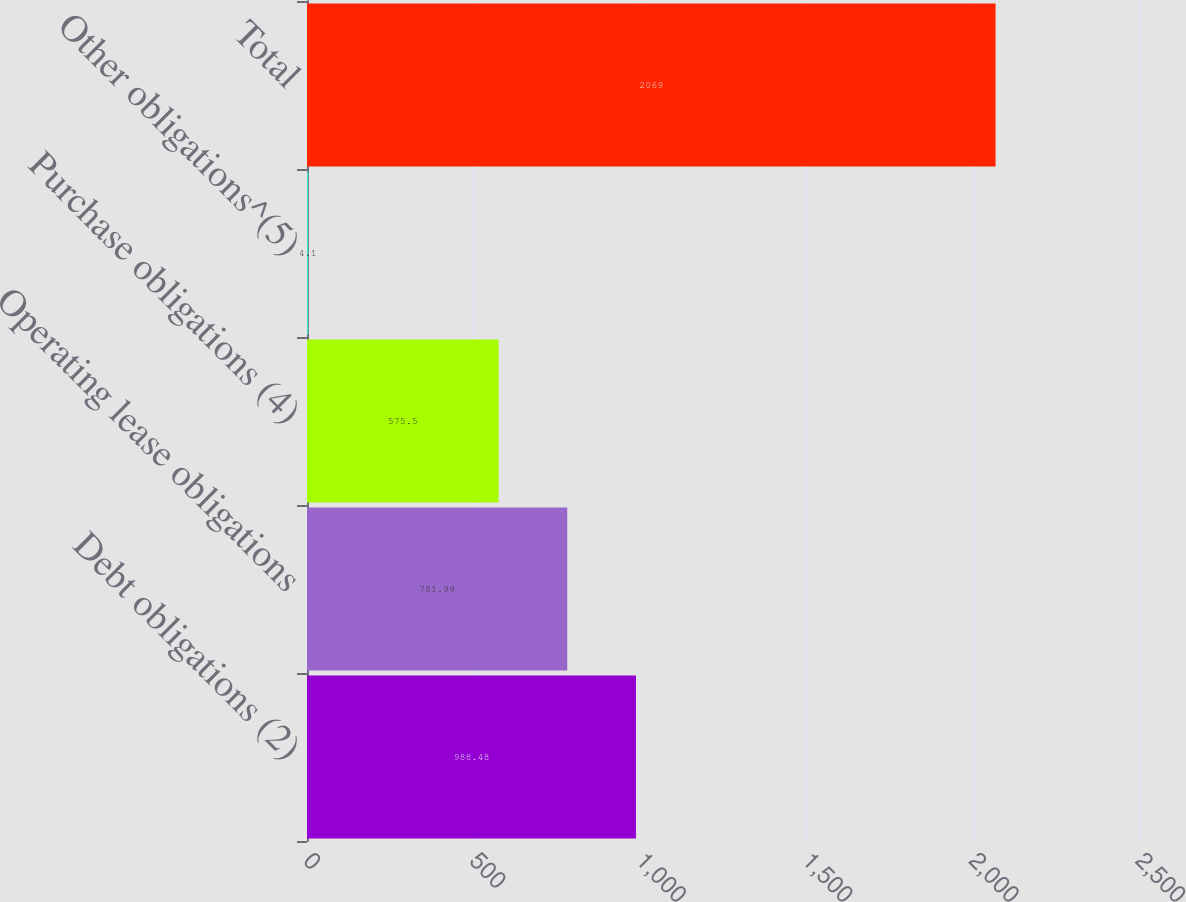Convert chart to OTSL. <chart><loc_0><loc_0><loc_500><loc_500><bar_chart><fcel>Debt obligations (2)<fcel>Operating lease obligations<fcel>Purchase obligations (4)<fcel>Other obligations^(5)<fcel>Total<nl><fcel>988.48<fcel>781.99<fcel>575.5<fcel>4.1<fcel>2069<nl></chart> 